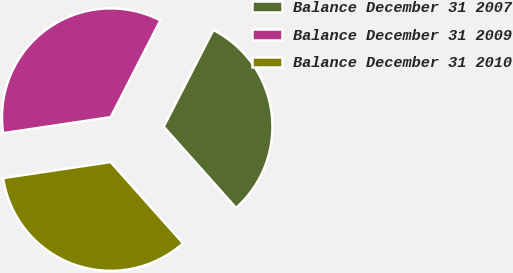Convert chart. <chart><loc_0><loc_0><loc_500><loc_500><pie_chart><fcel>Balance December 31 2007<fcel>Balance December 31 2009<fcel>Balance December 31 2010<nl><fcel>30.87%<fcel>34.9%<fcel>34.23%<nl></chart> 